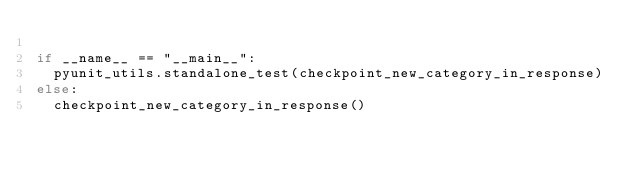<code> <loc_0><loc_0><loc_500><loc_500><_Python_>
if __name__ == "__main__":
  pyunit_utils.standalone_test(checkpoint_new_category_in_response)
else:
  checkpoint_new_category_in_response()</code> 